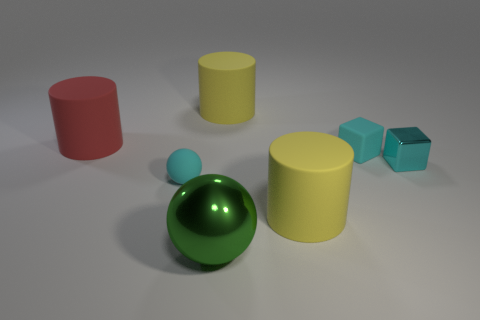Which objects in the image could easily roll if pushed? The spherical objects, namely the big green sphere and the smaller blue sphere, could easily roll if pushed due to their round shape. 